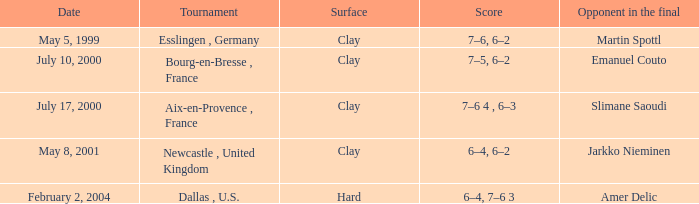What is the Opponent in the final of the game on february 2, 2004? Amer Delic. 